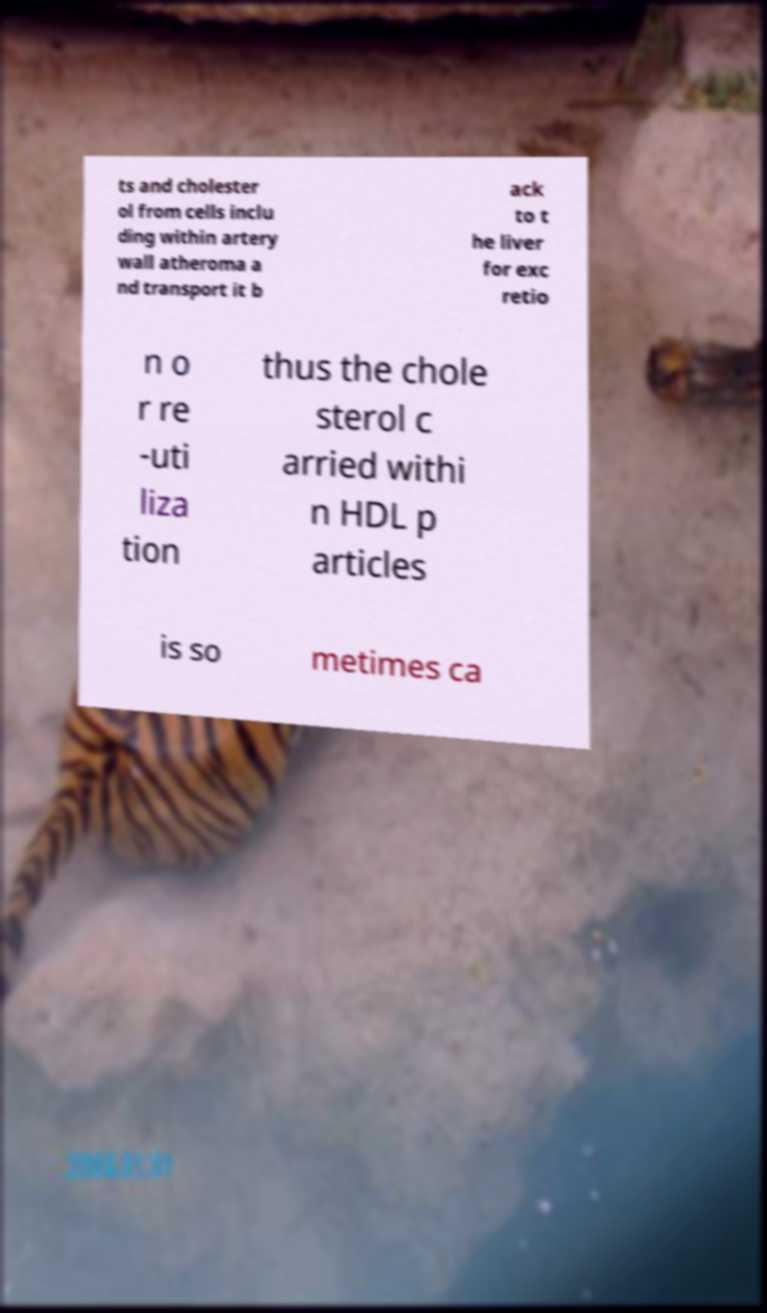What messages or text are displayed in this image? I need them in a readable, typed format. ts and cholester ol from cells inclu ding within artery wall atheroma a nd transport it b ack to t he liver for exc retio n o r re -uti liza tion thus the chole sterol c arried withi n HDL p articles is so metimes ca 